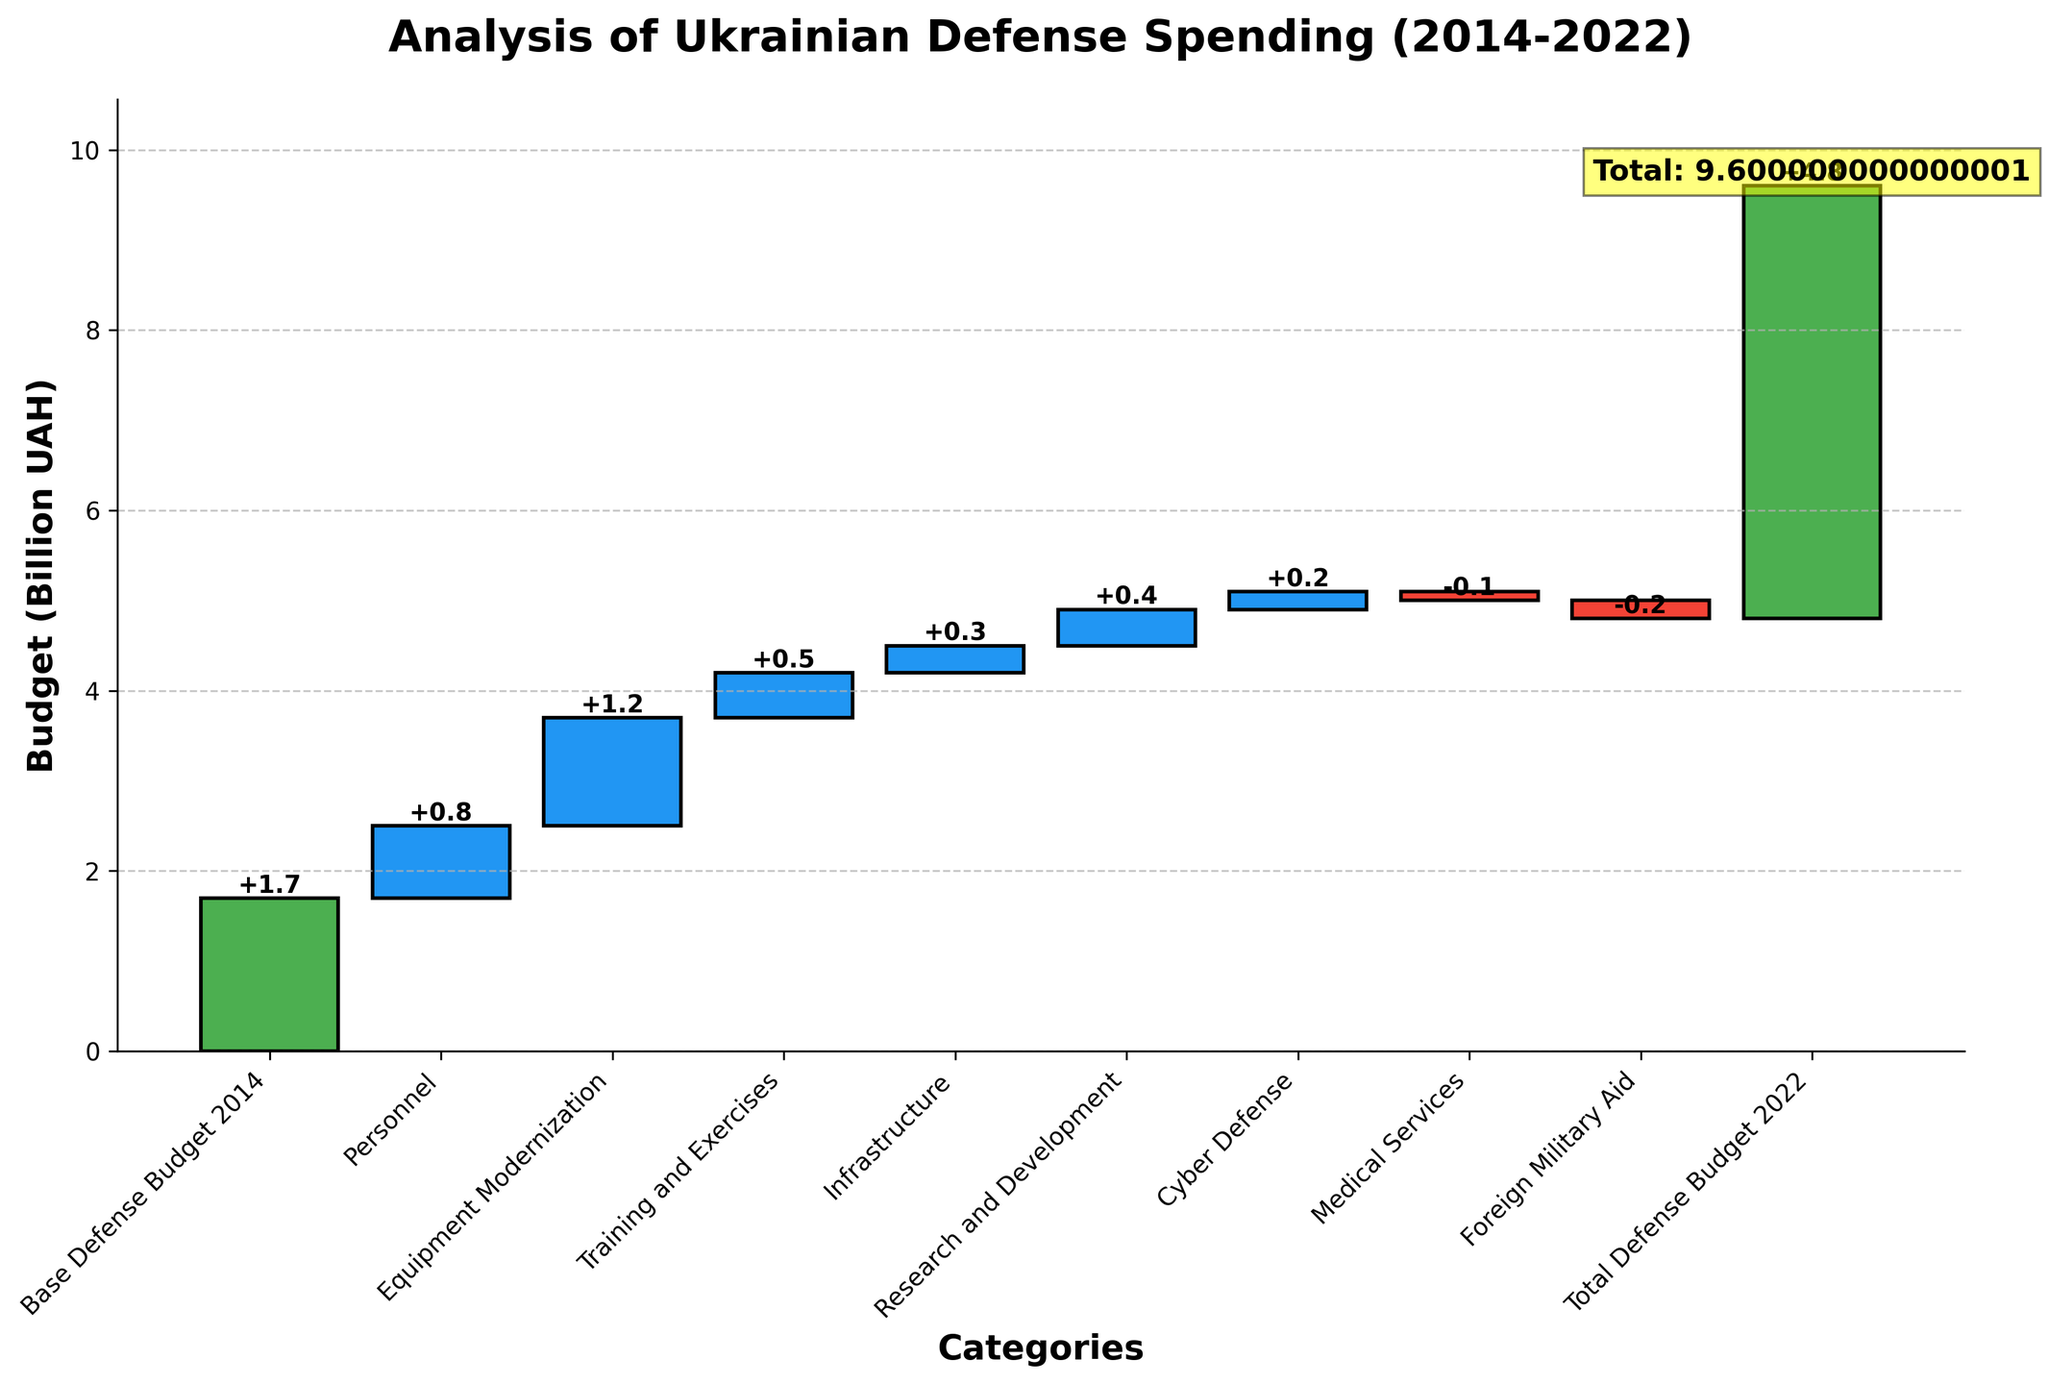What's the title of the figure? The title is usually placed at the top of the figure in a larger, bold font to summarize the content. Here, the title is "Analysis of Ukrainian Defense Spending (2014-2022)."
Answer: Analysis of Ukrainian Defense Spending (2014-2022) Which categories have an increase in value? In the Waterfall Chart, the bars with positive values are colored differently for easy identification. Positive bars here are: Personnel, Equipment Modernization, Training and Exercises, Infrastructure, Research and Development, and Cyber Defense.
Answer: Personnel, Equipment Modernization, Training and Exercises, Infrastructure, Research and Development, Cyber Defense What is the value change for Medical Services? In the figure, each bar represents a value change, and the label on each bar provides the easy-to-read numerical value. The bar for Medical Services shows a value of -0.1.
Answer: -0.1 How does the value for Personnel compare to Cyber Defense? The comparison can be made by observing and comparing the height and labels of the respective bars. The Personnel bar has a value of +0.8 while Cyber Defense has a value of +0.2.
Answer: Personnel is greater than Cyber Defense What is the overall increase from Equipment Modernization and Cyber Defense combined? To find the combined increase, sum the values of Equipment Modernization (+1.2) and Cyber Defense (+0.2), which is calculated as 1.2 + 0.2 = 1.4.
Answer: 1.4 Identify the categories that show a decrease in value. In the Waterfall Chart, decreases are usually shown in different colors for contrast. The categories with bars showing a negative change (decreases) are Medical Services and Foreign Military Aid.
Answer: Medical Services, Foreign Military Aid What is the sum of values for Research and Development, and Infrastructure? The sum can be calculated by adding the values of both categories: Research and Development (+0.4) and Infrastructure (+0.3). So, 0.4 + 0.3 = 0.7.
Answer: 0.7 What is the total budget in 2022? As labeled at the end of the Waterfall Chart in green with a summary label, the total budget for 2022 is 4.8 billion UAH.
Answer: 4.8 What is the overall change in budget from 2014 to 2022? Calculate the total change using the starting and ending values from the chart. The starting budget in 2014 is 1.7 billion UAH and the total budget in 2022 is 4.8 billion UAH. The overall change is 4.8 - 1.7 = 3.1 billion UAH.
Answer: 3.1 billion UAH 